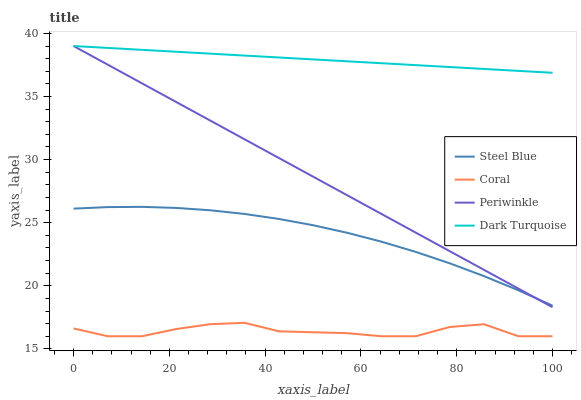Does Periwinkle have the minimum area under the curve?
Answer yes or no. No. Does Periwinkle have the maximum area under the curve?
Answer yes or no. No. Is Coral the smoothest?
Answer yes or no. No. Is Periwinkle the roughest?
Answer yes or no. No. Does Periwinkle have the lowest value?
Answer yes or no. No. Does Coral have the highest value?
Answer yes or no. No. Is Coral less than Dark Turquoise?
Answer yes or no. Yes. Is Dark Turquoise greater than Coral?
Answer yes or no. Yes. Does Coral intersect Dark Turquoise?
Answer yes or no. No. 